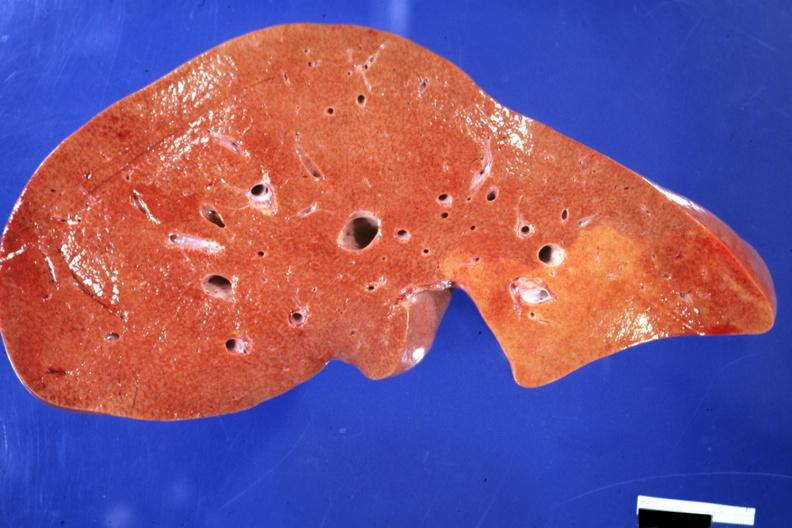s hepatobiliary present?
Answer the question using a single word or phrase. Yes 